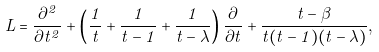<formula> <loc_0><loc_0><loc_500><loc_500>L = \frac { \partial ^ { 2 } } { \partial t ^ { 2 } } + \left ( \frac { 1 } { t } + \frac { 1 } { t - 1 } + \frac { 1 } { t - \lambda } \right ) \frac { \partial } { \partial t } + \frac { t - \beta } { t ( t - 1 ) ( t - \lambda ) } ,</formula> 